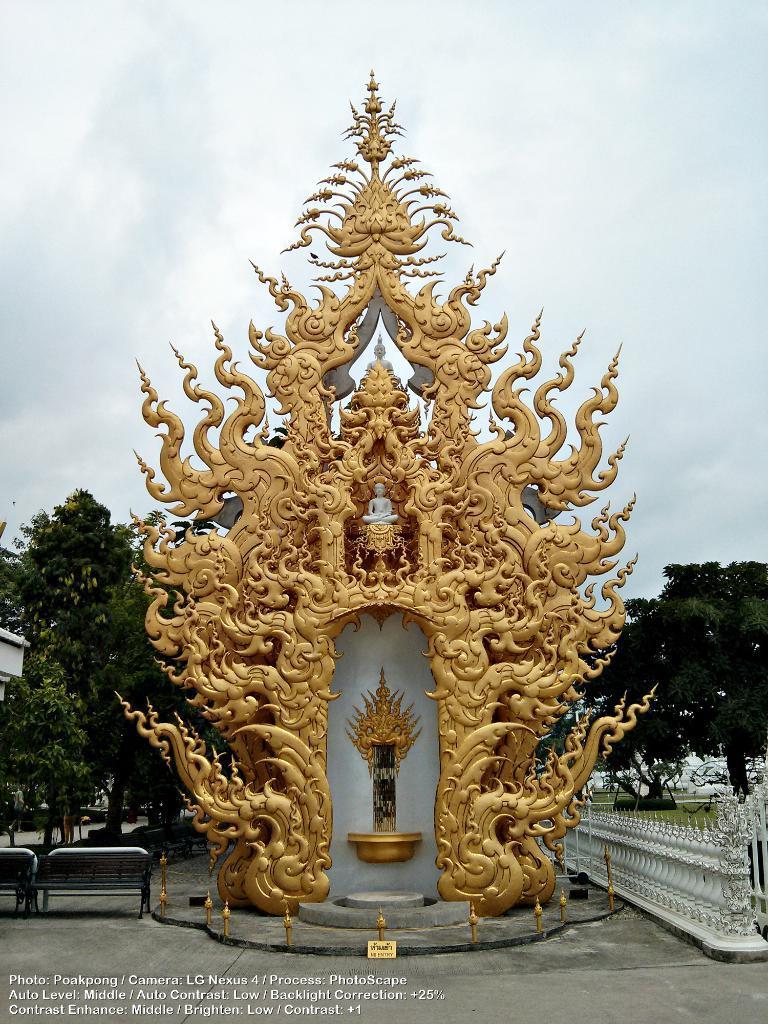Please provide a concise description of this image. In this image we can see a statue. We can also see some benches and a fence beside it. On the backside we can see some trees and the sky which looks cloudy. 